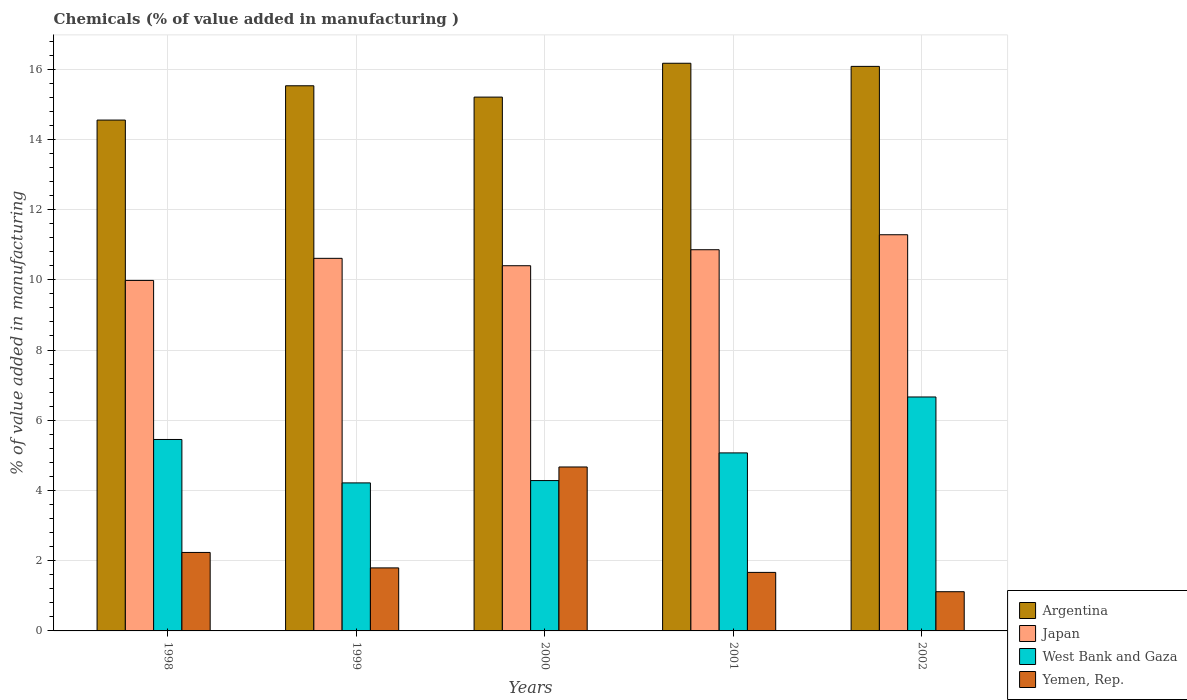How many groups of bars are there?
Give a very brief answer. 5. Are the number of bars on each tick of the X-axis equal?
Keep it short and to the point. Yes. How many bars are there on the 1st tick from the left?
Provide a short and direct response. 4. How many bars are there on the 1st tick from the right?
Give a very brief answer. 4. What is the label of the 1st group of bars from the left?
Provide a succinct answer. 1998. In how many cases, is the number of bars for a given year not equal to the number of legend labels?
Offer a very short reply. 0. What is the value added in manufacturing chemicals in Argentina in 2001?
Your answer should be compact. 16.17. Across all years, what is the maximum value added in manufacturing chemicals in Argentina?
Offer a terse response. 16.17. Across all years, what is the minimum value added in manufacturing chemicals in Japan?
Ensure brevity in your answer.  9.98. What is the total value added in manufacturing chemicals in West Bank and Gaza in the graph?
Your answer should be compact. 25.68. What is the difference between the value added in manufacturing chemicals in West Bank and Gaza in 1999 and that in 2001?
Make the answer very short. -0.85. What is the difference between the value added in manufacturing chemicals in Japan in 1998 and the value added in manufacturing chemicals in Argentina in 2002?
Give a very brief answer. -6.1. What is the average value added in manufacturing chemicals in Yemen, Rep. per year?
Your response must be concise. 2.3. In the year 1998, what is the difference between the value added in manufacturing chemicals in Argentina and value added in manufacturing chemicals in West Bank and Gaza?
Provide a short and direct response. 9.1. What is the ratio of the value added in manufacturing chemicals in Yemen, Rep. in 2000 to that in 2001?
Your answer should be very brief. 2.8. Is the value added in manufacturing chemicals in Japan in 2001 less than that in 2002?
Provide a short and direct response. Yes. What is the difference between the highest and the second highest value added in manufacturing chemicals in Argentina?
Your response must be concise. 0.09. What is the difference between the highest and the lowest value added in manufacturing chemicals in West Bank and Gaza?
Give a very brief answer. 2.45. In how many years, is the value added in manufacturing chemicals in Japan greater than the average value added in manufacturing chemicals in Japan taken over all years?
Your answer should be compact. 2. Is the sum of the value added in manufacturing chemicals in Japan in 1998 and 1999 greater than the maximum value added in manufacturing chemicals in Argentina across all years?
Offer a terse response. Yes. Is it the case that in every year, the sum of the value added in manufacturing chemicals in West Bank and Gaza and value added in manufacturing chemicals in Japan is greater than the sum of value added in manufacturing chemicals in Argentina and value added in manufacturing chemicals in Yemen, Rep.?
Your answer should be very brief. Yes. What does the 3rd bar from the left in 1999 represents?
Provide a short and direct response. West Bank and Gaza. What does the 4th bar from the right in 1998 represents?
Give a very brief answer. Argentina. Is it the case that in every year, the sum of the value added in manufacturing chemicals in Japan and value added in manufacturing chemicals in West Bank and Gaza is greater than the value added in manufacturing chemicals in Argentina?
Offer a terse response. No. How many bars are there?
Your response must be concise. 20. Are the values on the major ticks of Y-axis written in scientific E-notation?
Your answer should be compact. No. Does the graph contain any zero values?
Offer a terse response. No. Does the graph contain grids?
Offer a terse response. Yes. Where does the legend appear in the graph?
Offer a terse response. Bottom right. How many legend labels are there?
Your answer should be very brief. 4. How are the legend labels stacked?
Offer a very short reply. Vertical. What is the title of the graph?
Make the answer very short. Chemicals (% of value added in manufacturing ). Does "Sub-Saharan Africa (developing only)" appear as one of the legend labels in the graph?
Your answer should be compact. No. What is the label or title of the Y-axis?
Give a very brief answer. % of value added in manufacturing. What is the % of value added in manufacturing in Argentina in 1998?
Keep it short and to the point. 14.55. What is the % of value added in manufacturing of Japan in 1998?
Ensure brevity in your answer.  9.98. What is the % of value added in manufacturing in West Bank and Gaza in 1998?
Make the answer very short. 5.45. What is the % of value added in manufacturing in Yemen, Rep. in 1998?
Keep it short and to the point. 2.23. What is the % of value added in manufacturing of Argentina in 1999?
Your answer should be very brief. 15.53. What is the % of value added in manufacturing in Japan in 1999?
Make the answer very short. 10.61. What is the % of value added in manufacturing in West Bank and Gaza in 1999?
Make the answer very short. 4.22. What is the % of value added in manufacturing of Yemen, Rep. in 1999?
Provide a short and direct response. 1.79. What is the % of value added in manufacturing in Argentina in 2000?
Ensure brevity in your answer.  15.2. What is the % of value added in manufacturing of Japan in 2000?
Offer a terse response. 10.4. What is the % of value added in manufacturing in West Bank and Gaza in 2000?
Offer a very short reply. 4.28. What is the % of value added in manufacturing of Yemen, Rep. in 2000?
Keep it short and to the point. 4.67. What is the % of value added in manufacturing of Argentina in 2001?
Your answer should be very brief. 16.17. What is the % of value added in manufacturing in Japan in 2001?
Offer a very short reply. 10.86. What is the % of value added in manufacturing of West Bank and Gaza in 2001?
Your response must be concise. 5.07. What is the % of value added in manufacturing of Yemen, Rep. in 2001?
Provide a short and direct response. 1.67. What is the % of value added in manufacturing of Argentina in 2002?
Ensure brevity in your answer.  16.08. What is the % of value added in manufacturing of Japan in 2002?
Keep it short and to the point. 11.28. What is the % of value added in manufacturing in West Bank and Gaza in 2002?
Provide a succinct answer. 6.66. What is the % of value added in manufacturing in Yemen, Rep. in 2002?
Keep it short and to the point. 1.12. Across all years, what is the maximum % of value added in manufacturing in Argentina?
Provide a succinct answer. 16.17. Across all years, what is the maximum % of value added in manufacturing in Japan?
Ensure brevity in your answer.  11.28. Across all years, what is the maximum % of value added in manufacturing of West Bank and Gaza?
Provide a succinct answer. 6.66. Across all years, what is the maximum % of value added in manufacturing in Yemen, Rep.?
Your answer should be compact. 4.67. Across all years, what is the minimum % of value added in manufacturing of Argentina?
Offer a terse response. 14.55. Across all years, what is the minimum % of value added in manufacturing of Japan?
Your answer should be compact. 9.98. Across all years, what is the minimum % of value added in manufacturing of West Bank and Gaza?
Make the answer very short. 4.22. Across all years, what is the minimum % of value added in manufacturing of Yemen, Rep.?
Provide a succinct answer. 1.12. What is the total % of value added in manufacturing in Argentina in the graph?
Provide a succinct answer. 77.52. What is the total % of value added in manufacturing of Japan in the graph?
Your answer should be very brief. 53.13. What is the total % of value added in manufacturing in West Bank and Gaza in the graph?
Ensure brevity in your answer.  25.68. What is the total % of value added in manufacturing in Yemen, Rep. in the graph?
Provide a succinct answer. 11.48. What is the difference between the % of value added in manufacturing in Argentina in 1998 and that in 1999?
Ensure brevity in your answer.  -0.98. What is the difference between the % of value added in manufacturing of Japan in 1998 and that in 1999?
Ensure brevity in your answer.  -0.63. What is the difference between the % of value added in manufacturing of West Bank and Gaza in 1998 and that in 1999?
Your response must be concise. 1.24. What is the difference between the % of value added in manufacturing in Yemen, Rep. in 1998 and that in 1999?
Offer a very short reply. 0.44. What is the difference between the % of value added in manufacturing in Argentina in 1998 and that in 2000?
Offer a terse response. -0.65. What is the difference between the % of value added in manufacturing of Japan in 1998 and that in 2000?
Offer a very short reply. -0.42. What is the difference between the % of value added in manufacturing of West Bank and Gaza in 1998 and that in 2000?
Offer a very short reply. 1.17. What is the difference between the % of value added in manufacturing of Yemen, Rep. in 1998 and that in 2000?
Give a very brief answer. -2.43. What is the difference between the % of value added in manufacturing in Argentina in 1998 and that in 2001?
Keep it short and to the point. -1.62. What is the difference between the % of value added in manufacturing in Japan in 1998 and that in 2001?
Provide a succinct answer. -0.87. What is the difference between the % of value added in manufacturing in West Bank and Gaza in 1998 and that in 2001?
Keep it short and to the point. 0.38. What is the difference between the % of value added in manufacturing in Yemen, Rep. in 1998 and that in 2001?
Make the answer very short. 0.57. What is the difference between the % of value added in manufacturing of Argentina in 1998 and that in 2002?
Offer a terse response. -1.53. What is the difference between the % of value added in manufacturing in Japan in 1998 and that in 2002?
Give a very brief answer. -1.3. What is the difference between the % of value added in manufacturing in West Bank and Gaza in 1998 and that in 2002?
Give a very brief answer. -1.21. What is the difference between the % of value added in manufacturing of Yemen, Rep. in 1998 and that in 2002?
Your answer should be compact. 1.12. What is the difference between the % of value added in manufacturing of Argentina in 1999 and that in 2000?
Ensure brevity in your answer.  0.32. What is the difference between the % of value added in manufacturing in Japan in 1999 and that in 2000?
Ensure brevity in your answer.  0.21. What is the difference between the % of value added in manufacturing of West Bank and Gaza in 1999 and that in 2000?
Your answer should be very brief. -0.07. What is the difference between the % of value added in manufacturing in Yemen, Rep. in 1999 and that in 2000?
Offer a very short reply. -2.87. What is the difference between the % of value added in manufacturing of Argentina in 1999 and that in 2001?
Give a very brief answer. -0.64. What is the difference between the % of value added in manufacturing in Japan in 1999 and that in 2001?
Make the answer very short. -0.25. What is the difference between the % of value added in manufacturing in West Bank and Gaza in 1999 and that in 2001?
Keep it short and to the point. -0.85. What is the difference between the % of value added in manufacturing in Yemen, Rep. in 1999 and that in 2001?
Provide a short and direct response. 0.13. What is the difference between the % of value added in manufacturing of Argentina in 1999 and that in 2002?
Make the answer very short. -0.55. What is the difference between the % of value added in manufacturing in Japan in 1999 and that in 2002?
Your answer should be compact. -0.67. What is the difference between the % of value added in manufacturing of West Bank and Gaza in 1999 and that in 2002?
Ensure brevity in your answer.  -2.45. What is the difference between the % of value added in manufacturing of Yemen, Rep. in 1999 and that in 2002?
Your answer should be very brief. 0.68. What is the difference between the % of value added in manufacturing in Argentina in 2000 and that in 2001?
Your response must be concise. -0.96. What is the difference between the % of value added in manufacturing of Japan in 2000 and that in 2001?
Your response must be concise. -0.46. What is the difference between the % of value added in manufacturing of West Bank and Gaza in 2000 and that in 2001?
Offer a terse response. -0.79. What is the difference between the % of value added in manufacturing of Yemen, Rep. in 2000 and that in 2001?
Offer a very short reply. 3. What is the difference between the % of value added in manufacturing of Argentina in 2000 and that in 2002?
Make the answer very short. -0.87. What is the difference between the % of value added in manufacturing of Japan in 2000 and that in 2002?
Offer a very short reply. -0.88. What is the difference between the % of value added in manufacturing of West Bank and Gaza in 2000 and that in 2002?
Your response must be concise. -2.38. What is the difference between the % of value added in manufacturing in Yemen, Rep. in 2000 and that in 2002?
Ensure brevity in your answer.  3.55. What is the difference between the % of value added in manufacturing in Argentina in 2001 and that in 2002?
Your response must be concise. 0.09. What is the difference between the % of value added in manufacturing in Japan in 2001 and that in 2002?
Provide a succinct answer. -0.43. What is the difference between the % of value added in manufacturing of West Bank and Gaza in 2001 and that in 2002?
Your answer should be compact. -1.59. What is the difference between the % of value added in manufacturing of Yemen, Rep. in 2001 and that in 2002?
Your response must be concise. 0.55. What is the difference between the % of value added in manufacturing in Argentina in 1998 and the % of value added in manufacturing in Japan in 1999?
Provide a short and direct response. 3.94. What is the difference between the % of value added in manufacturing in Argentina in 1998 and the % of value added in manufacturing in West Bank and Gaza in 1999?
Your response must be concise. 10.33. What is the difference between the % of value added in manufacturing in Argentina in 1998 and the % of value added in manufacturing in Yemen, Rep. in 1999?
Provide a short and direct response. 12.75. What is the difference between the % of value added in manufacturing of Japan in 1998 and the % of value added in manufacturing of West Bank and Gaza in 1999?
Give a very brief answer. 5.77. What is the difference between the % of value added in manufacturing in Japan in 1998 and the % of value added in manufacturing in Yemen, Rep. in 1999?
Offer a very short reply. 8.19. What is the difference between the % of value added in manufacturing in West Bank and Gaza in 1998 and the % of value added in manufacturing in Yemen, Rep. in 1999?
Your answer should be compact. 3.66. What is the difference between the % of value added in manufacturing in Argentina in 1998 and the % of value added in manufacturing in Japan in 2000?
Give a very brief answer. 4.15. What is the difference between the % of value added in manufacturing of Argentina in 1998 and the % of value added in manufacturing of West Bank and Gaza in 2000?
Make the answer very short. 10.27. What is the difference between the % of value added in manufacturing of Argentina in 1998 and the % of value added in manufacturing of Yemen, Rep. in 2000?
Offer a terse response. 9.88. What is the difference between the % of value added in manufacturing of Japan in 1998 and the % of value added in manufacturing of West Bank and Gaza in 2000?
Provide a succinct answer. 5.7. What is the difference between the % of value added in manufacturing of Japan in 1998 and the % of value added in manufacturing of Yemen, Rep. in 2000?
Offer a terse response. 5.31. What is the difference between the % of value added in manufacturing in West Bank and Gaza in 1998 and the % of value added in manufacturing in Yemen, Rep. in 2000?
Provide a succinct answer. 0.78. What is the difference between the % of value added in manufacturing in Argentina in 1998 and the % of value added in manufacturing in Japan in 2001?
Make the answer very short. 3.69. What is the difference between the % of value added in manufacturing in Argentina in 1998 and the % of value added in manufacturing in West Bank and Gaza in 2001?
Provide a succinct answer. 9.48. What is the difference between the % of value added in manufacturing of Argentina in 1998 and the % of value added in manufacturing of Yemen, Rep. in 2001?
Offer a very short reply. 12.88. What is the difference between the % of value added in manufacturing of Japan in 1998 and the % of value added in manufacturing of West Bank and Gaza in 2001?
Give a very brief answer. 4.91. What is the difference between the % of value added in manufacturing of Japan in 1998 and the % of value added in manufacturing of Yemen, Rep. in 2001?
Your answer should be compact. 8.32. What is the difference between the % of value added in manufacturing in West Bank and Gaza in 1998 and the % of value added in manufacturing in Yemen, Rep. in 2001?
Offer a terse response. 3.79. What is the difference between the % of value added in manufacturing in Argentina in 1998 and the % of value added in manufacturing in Japan in 2002?
Your response must be concise. 3.27. What is the difference between the % of value added in manufacturing of Argentina in 1998 and the % of value added in manufacturing of West Bank and Gaza in 2002?
Provide a succinct answer. 7.89. What is the difference between the % of value added in manufacturing in Argentina in 1998 and the % of value added in manufacturing in Yemen, Rep. in 2002?
Offer a terse response. 13.43. What is the difference between the % of value added in manufacturing of Japan in 1998 and the % of value added in manufacturing of West Bank and Gaza in 2002?
Your answer should be very brief. 3.32. What is the difference between the % of value added in manufacturing of Japan in 1998 and the % of value added in manufacturing of Yemen, Rep. in 2002?
Provide a short and direct response. 8.87. What is the difference between the % of value added in manufacturing of West Bank and Gaza in 1998 and the % of value added in manufacturing of Yemen, Rep. in 2002?
Your answer should be compact. 4.34. What is the difference between the % of value added in manufacturing of Argentina in 1999 and the % of value added in manufacturing of Japan in 2000?
Your response must be concise. 5.12. What is the difference between the % of value added in manufacturing in Argentina in 1999 and the % of value added in manufacturing in West Bank and Gaza in 2000?
Offer a terse response. 11.24. What is the difference between the % of value added in manufacturing of Argentina in 1999 and the % of value added in manufacturing of Yemen, Rep. in 2000?
Give a very brief answer. 10.86. What is the difference between the % of value added in manufacturing of Japan in 1999 and the % of value added in manufacturing of West Bank and Gaza in 2000?
Your response must be concise. 6.33. What is the difference between the % of value added in manufacturing of Japan in 1999 and the % of value added in manufacturing of Yemen, Rep. in 2000?
Provide a succinct answer. 5.94. What is the difference between the % of value added in manufacturing of West Bank and Gaza in 1999 and the % of value added in manufacturing of Yemen, Rep. in 2000?
Your response must be concise. -0.45. What is the difference between the % of value added in manufacturing in Argentina in 1999 and the % of value added in manufacturing in Japan in 2001?
Make the answer very short. 4.67. What is the difference between the % of value added in manufacturing of Argentina in 1999 and the % of value added in manufacturing of West Bank and Gaza in 2001?
Your answer should be very brief. 10.46. What is the difference between the % of value added in manufacturing in Argentina in 1999 and the % of value added in manufacturing in Yemen, Rep. in 2001?
Make the answer very short. 13.86. What is the difference between the % of value added in manufacturing in Japan in 1999 and the % of value added in manufacturing in West Bank and Gaza in 2001?
Your answer should be very brief. 5.54. What is the difference between the % of value added in manufacturing in Japan in 1999 and the % of value added in manufacturing in Yemen, Rep. in 2001?
Keep it short and to the point. 8.94. What is the difference between the % of value added in manufacturing in West Bank and Gaza in 1999 and the % of value added in manufacturing in Yemen, Rep. in 2001?
Provide a short and direct response. 2.55. What is the difference between the % of value added in manufacturing in Argentina in 1999 and the % of value added in manufacturing in Japan in 2002?
Offer a very short reply. 4.24. What is the difference between the % of value added in manufacturing of Argentina in 1999 and the % of value added in manufacturing of West Bank and Gaza in 2002?
Keep it short and to the point. 8.86. What is the difference between the % of value added in manufacturing of Argentina in 1999 and the % of value added in manufacturing of Yemen, Rep. in 2002?
Keep it short and to the point. 14.41. What is the difference between the % of value added in manufacturing in Japan in 1999 and the % of value added in manufacturing in West Bank and Gaza in 2002?
Give a very brief answer. 3.95. What is the difference between the % of value added in manufacturing of Japan in 1999 and the % of value added in manufacturing of Yemen, Rep. in 2002?
Ensure brevity in your answer.  9.49. What is the difference between the % of value added in manufacturing in West Bank and Gaza in 1999 and the % of value added in manufacturing in Yemen, Rep. in 2002?
Provide a short and direct response. 3.1. What is the difference between the % of value added in manufacturing in Argentina in 2000 and the % of value added in manufacturing in Japan in 2001?
Provide a succinct answer. 4.35. What is the difference between the % of value added in manufacturing in Argentina in 2000 and the % of value added in manufacturing in West Bank and Gaza in 2001?
Your answer should be very brief. 10.13. What is the difference between the % of value added in manufacturing in Argentina in 2000 and the % of value added in manufacturing in Yemen, Rep. in 2001?
Ensure brevity in your answer.  13.54. What is the difference between the % of value added in manufacturing of Japan in 2000 and the % of value added in manufacturing of West Bank and Gaza in 2001?
Your answer should be compact. 5.33. What is the difference between the % of value added in manufacturing in Japan in 2000 and the % of value added in manufacturing in Yemen, Rep. in 2001?
Your answer should be very brief. 8.73. What is the difference between the % of value added in manufacturing in West Bank and Gaza in 2000 and the % of value added in manufacturing in Yemen, Rep. in 2001?
Give a very brief answer. 2.62. What is the difference between the % of value added in manufacturing of Argentina in 2000 and the % of value added in manufacturing of Japan in 2002?
Provide a succinct answer. 3.92. What is the difference between the % of value added in manufacturing of Argentina in 2000 and the % of value added in manufacturing of West Bank and Gaza in 2002?
Make the answer very short. 8.54. What is the difference between the % of value added in manufacturing of Argentina in 2000 and the % of value added in manufacturing of Yemen, Rep. in 2002?
Provide a short and direct response. 14.09. What is the difference between the % of value added in manufacturing of Japan in 2000 and the % of value added in manufacturing of West Bank and Gaza in 2002?
Provide a succinct answer. 3.74. What is the difference between the % of value added in manufacturing of Japan in 2000 and the % of value added in manufacturing of Yemen, Rep. in 2002?
Provide a succinct answer. 9.28. What is the difference between the % of value added in manufacturing of West Bank and Gaza in 2000 and the % of value added in manufacturing of Yemen, Rep. in 2002?
Your answer should be compact. 3.17. What is the difference between the % of value added in manufacturing of Argentina in 2001 and the % of value added in manufacturing of Japan in 2002?
Provide a succinct answer. 4.88. What is the difference between the % of value added in manufacturing of Argentina in 2001 and the % of value added in manufacturing of West Bank and Gaza in 2002?
Provide a succinct answer. 9.5. What is the difference between the % of value added in manufacturing of Argentina in 2001 and the % of value added in manufacturing of Yemen, Rep. in 2002?
Give a very brief answer. 15.05. What is the difference between the % of value added in manufacturing in Japan in 2001 and the % of value added in manufacturing in West Bank and Gaza in 2002?
Your answer should be compact. 4.19. What is the difference between the % of value added in manufacturing of Japan in 2001 and the % of value added in manufacturing of Yemen, Rep. in 2002?
Offer a very short reply. 9.74. What is the difference between the % of value added in manufacturing of West Bank and Gaza in 2001 and the % of value added in manufacturing of Yemen, Rep. in 2002?
Keep it short and to the point. 3.95. What is the average % of value added in manufacturing in Argentina per year?
Your response must be concise. 15.5. What is the average % of value added in manufacturing in Japan per year?
Offer a terse response. 10.63. What is the average % of value added in manufacturing of West Bank and Gaza per year?
Provide a short and direct response. 5.14. What is the average % of value added in manufacturing of Yemen, Rep. per year?
Keep it short and to the point. 2.3. In the year 1998, what is the difference between the % of value added in manufacturing in Argentina and % of value added in manufacturing in Japan?
Your response must be concise. 4.57. In the year 1998, what is the difference between the % of value added in manufacturing of Argentina and % of value added in manufacturing of West Bank and Gaza?
Offer a very short reply. 9.1. In the year 1998, what is the difference between the % of value added in manufacturing in Argentina and % of value added in manufacturing in Yemen, Rep.?
Provide a short and direct response. 12.31. In the year 1998, what is the difference between the % of value added in manufacturing in Japan and % of value added in manufacturing in West Bank and Gaza?
Provide a succinct answer. 4.53. In the year 1998, what is the difference between the % of value added in manufacturing of Japan and % of value added in manufacturing of Yemen, Rep.?
Your response must be concise. 7.75. In the year 1998, what is the difference between the % of value added in manufacturing in West Bank and Gaza and % of value added in manufacturing in Yemen, Rep.?
Provide a short and direct response. 3.22. In the year 1999, what is the difference between the % of value added in manufacturing of Argentina and % of value added in manufacturing of Japan?
Offer a very short reply. 4.91. In the year 1999, what is the difference between the % of value added in manufacturing of Argentina and % of value added in manufacturing of West Bank and Gaza?
Ensure brevity in your answer.  11.31. In the year 1999, what is the difference between the % of value added in manufacturing in Argentina and % of value added in manufacturing in Yemen, Rep.?
Ensure brevity in your answer.  13.73. In the year 1999, what is the difference between the % of value added in manufacturing in Japan and % of value added in manufacturing in West Bank and Gaza?
Ensure brevity in your answer.  6.39. In the year 1999, what is the difference between the % of value added in manufacturing of Japan and % of value added in manufacturing of Yemen, Rep.?
Offer a very short reply. 8.82. In the year 1999, what is the difference between the % of value added in manufacturing of West Bank and Gaza and % of value added in manufacturing of Yemen, Rep.?
Provide a short and direct response. 2.42. In the year 2000, what is the difference between the % of value added in manufacturing of Argentina and % of value added in manufacturing of Japan?
Offer a terse response. 4.8. In the year 2000, what is the difference between the % of value added in manufacturing of Argentina and % of value added in manufacturing of West Bank and Gaza?
Provide a short and direct response. 10.92. In the year 2000, what is the difference between the % of value added in manufacturing in Argentina and % of value added in manufacturing in Yemen, Rep.?
Give a very brief answer. 10.53. In the year 2000, what is the difference between the % of value added in manufacturing in Japan and % of value added in manufacturing in West Bank and Gaza?
Offer a very short reply. 6.12. In the year 2000, what is the difference between the % of value added in manufacturing of Japan and % of value added in manufacturing of Yemen, Rep.?
Offer a very short reply. 5.73. In the year 2000, what is the difference between the % of value added in manufacturing in West Bank and Gaza and % of value added in manufacturing in Yemen, Rep.?
Offer a terse response. -0.39. In the year 2001, what is the difference between the % of value added in manufacturing of Argentina and % of value added in manufacturing of Japan?
Ensure brevity in your answer.  5.31. In the year 2001, what is the difference between the % of value added in manufacturing of Argentina and % of value added in manufacturing of West Bank and Gaza?
Provide a short and direct response. 11.1. In the year 2001, what is the difference between the % of value added in manufacturing of Argentina and % of value added in manufacturing of Yemen, Rep.?
Make the answer very short. 14.5. In the year 2001, what is the difference between the % of value added in manufacturing of Japan and % of value added in manufacturing of West Bank and Gaza?
Offer a terse response. 5.79. In the year 2001, what is the difference between the % of value added in manufacturing of Japan and % of value added in manufacturing of Yemen, Rep.?
Provide a succinct answer. 9.19. In the year 2001, what is the difference between the % of value added in manufacturing of West Bank and Gaza and % of value added in manufacturing of Yemen, Rep.?
Ensure brevity in your answer.  3.4. In the year 2002, what is the difference between the % of value added in manufacturing in Argentina and % of value added in manufacturing in Japan?
Make the answer very short. 4.79. In the year 2002, what is the difference between the % of value added in manufacturing of Argentina and % of value added in manufacturing of West Bank and Gaza?
Provide a short and direct response. 9.42. In the year 2002, what is the difference between the % of value added in manufacturing in Argentina and % of value added in manufacturing in Yemen, Rep.?
Your answer should be very brief. 14.96. In the year 2002, what is the difference between the % of value added in manufacturing in Japan and % of value added in manufacturing in West Bank and Gaza?
Your answer should be compact. 4.62. In the year 2002, what is the difference between the % of value added in manufacturing in Japan and % of value added in manufacturing in Yemen, Rep.?
Provide a short and direct response. 10.17. In the year 2002, what is the difference between the % of value added in manufacturing of West Bank and Gaza and % of value added in manufacturing of Yemen, Rep.?
Offer a terse response. 5.55. What is the ratio of the % of value added in manufacturing in Argentina in 1998 to that in 1999?
Give a very brief answer. 0.94. What is the ratio of the % of value added in manufacturing of Japan in 1998 to that in 1999?
Your answer should be compact. 0.94. What is the ratio of the % of value added in manufacturing in West Bank and Gaza in 1998 to that in 1999?
Your answer should be very brief. 1.29. What is the ratio of the % of value added in manufacturing in Yemen, Rep. in 1998 to that in 1999?
Provide a short and direct response. 1.25. What is the ratio of the % of value added in manufacturing of Argentina in 1998 to that in 2000?
Provide a succinct answer. 0.96. What is the ratio of the % of value added in manufacturing in Japan in 1998 to that in 2000?
Your answer should be very brief. 0.96. What is the ratio of the % of value added in manufacturing of West Bank and Gaza in 1998 to that in 2000?
Offer a very short reply. 1.27. What is the ratio of the % of value added in manufacturing of Yemen, Rep. in 1998 to that in 2000?
Give a very brief answer. 0.48. What is the ratio of the % of value added in manufacturing in Argentina in 1998 to that in 2001?
Your response must be concise. 0.9. What is the ratio of the % of value added in manufacturing in Japan in 1998 to that in 2001?
Make the answer very short. 0.92. What is the ratio of the % of value added in manufacturing in West Bank and Gaza in 1998 to that in 2001?
Your answer should be compact. 1.08. What is the ratio of the % of value added in manufacturing of Yemen, Rep. in 1998 to that in 2001?
Keep it short and to the point. 1.34. What is the ratio of the % of value added in manufacturing in Argentina in 1998 to that in 2002?
Offer a very short reply. 0.9. What is the ratio of the % of value added in manufacturing of Japan in 1998 to that in 2002?
Provide a short and direct response. 0.88. What is the ratio of the % of value added in manufacturing of West Bank and Gaza in 1998 to that in 2002?
Make the answer very short. 0.82. What is the ratio of the % of value added in manufacturing in Yemen, Rep. in 1998 to that in 2002?
Your response must be concise. 2. What is the ratio of the % of value added in manufacturing of Argentina in 1999 to that in 2000?
Your response must be concise. 1.02. What is the ratio of the % of value added in manufacturing of Japan in 1999 to that in 2000?
Offer a very short reply. 1.02. What is the ratio of the % of value added in manufacturing of West Bank and Gaza in 1999 to that in 2000?
Your answer should be compact. 0.98. What is the ratio of the % of value added in manufacturing of Yemen, Rep. in 1999 to that in 2000?
Your answer should be compact. 0.38. What is the ratio of the % of value added in manufacturing of Argentina in 1999 to that in 2001?
Your answer should be very brief. 0.96. What is the ratio of the % of value added in manufacturing in Japan in 1999 to that in 2001?
Provide a succinct answer. 0.98. What is the ratio of the % of value added in manufacturing of West Bank and Gaza in 1999 to that in 2001?
Your response must be concise. 0.83. What is the ratio of the % of value added in manufacturing of Yemen, Rep. in 1999 to that in 2001?
Offer a terse response. 1.08. What is the ratio of the % of value added in manufacturing of Argentina in 1999 to that in 2002?
Offer a terse response. 0.97. What is the ratio of the % of value added in manufacturing in Japan in 1999 to that in 2002?
Provide a succinct answer. 0.94. What is the ratio of the % of value added in manufacturing in West Bank and Gaza in 1999 to that in 2002?
Give a very brief answer. 0.63. What is the ratio of the % of value added in manufacturing of Yemen, Rep. in 1999 to that in 2002?
Offer a very short reply. 1.61. What is the ratio of the % of value added in manufacturing of Argentina in 2000 to that in 2001?
Your answer should be compact. 0.94. What is the ratio of the % of value added in manufacturing of Japan in 2000 to that in 2001?
Keep it short and to the point. 0.96. What is the ratio of the % of value added in manufacturing in West Bank and Gaza in 2000 to that in 2001?
Offer a very short reply. 0.84. What is the ratio of the % of value added in manufacturing of Yemen, Rep. in 2000 to that in 2001?
Provide a succinct answer. 2.8. What is the ratio of the % of value added in manufacturing of Argentina in 2000 to that in 2002?
Provide a succinct answer. 0.95. What is the ratio of the % of value added in manufacturing in Japan in 2000 to that in 2002?
Provide a short and direct response. 0.92. What is the ratio of the % of value added in manufacturing in West Bank and Gaza in 2000 to that in 2002?
Your answer should be compact. 0.64. What is the ratio of the % of value added in manufacturing in Yemen, Rep. in 2000 to that in 2002?
Your answer should be very brief. 4.18. What is the ratio of the % of value added in manufacturing of Japan in 2001 to that in 2002?
Ensure brevity in your answer.  0.96. What is the ratio of the % of value added in manufacturing in West Bank and Gaza in 2001 to that in 2002?
Offer a very short reply. 0.76. What is the ratio of the % of value added in manufacturing in Yemen, Rep. in 2001 to that in 2002?
Your answer should be very brief. 1.49. What is the difference between the highest and the second highest % of value added in manufacturing in Argentina?
Provide a short and direct response. 0.09. What is the difference between the highest and the second highest % of value added in manufacturing of Japan?
Your response must be concise. 0.43. What is the difference between the highest and the second highest % of value added in manufacturing in West Bank and Gaza?
Provide a succinct answer. 1.21. What is the difference between the highest and the second highest % of value added in manufacturing in Yemen, Rep.?
Your answer should be very brief. 2.43. What is the difference between the highest and the lowest % of value added in manufacturing of Argentina?
Offer a very short reply. 1.62. What is the difference between the highest and the lowest % of value added in manufacturing in Japan?
Give a very brief answer. 1.3. What is the difference between the highest and the lowest % of value added in manufacturing of West Bank and Gaza?
Provide a short and direct response. 2.45. What is the difference between the highest and the lowest % of value added in manufacturing in Yemen, Rep.?
Make the answer very short. 3.55. 